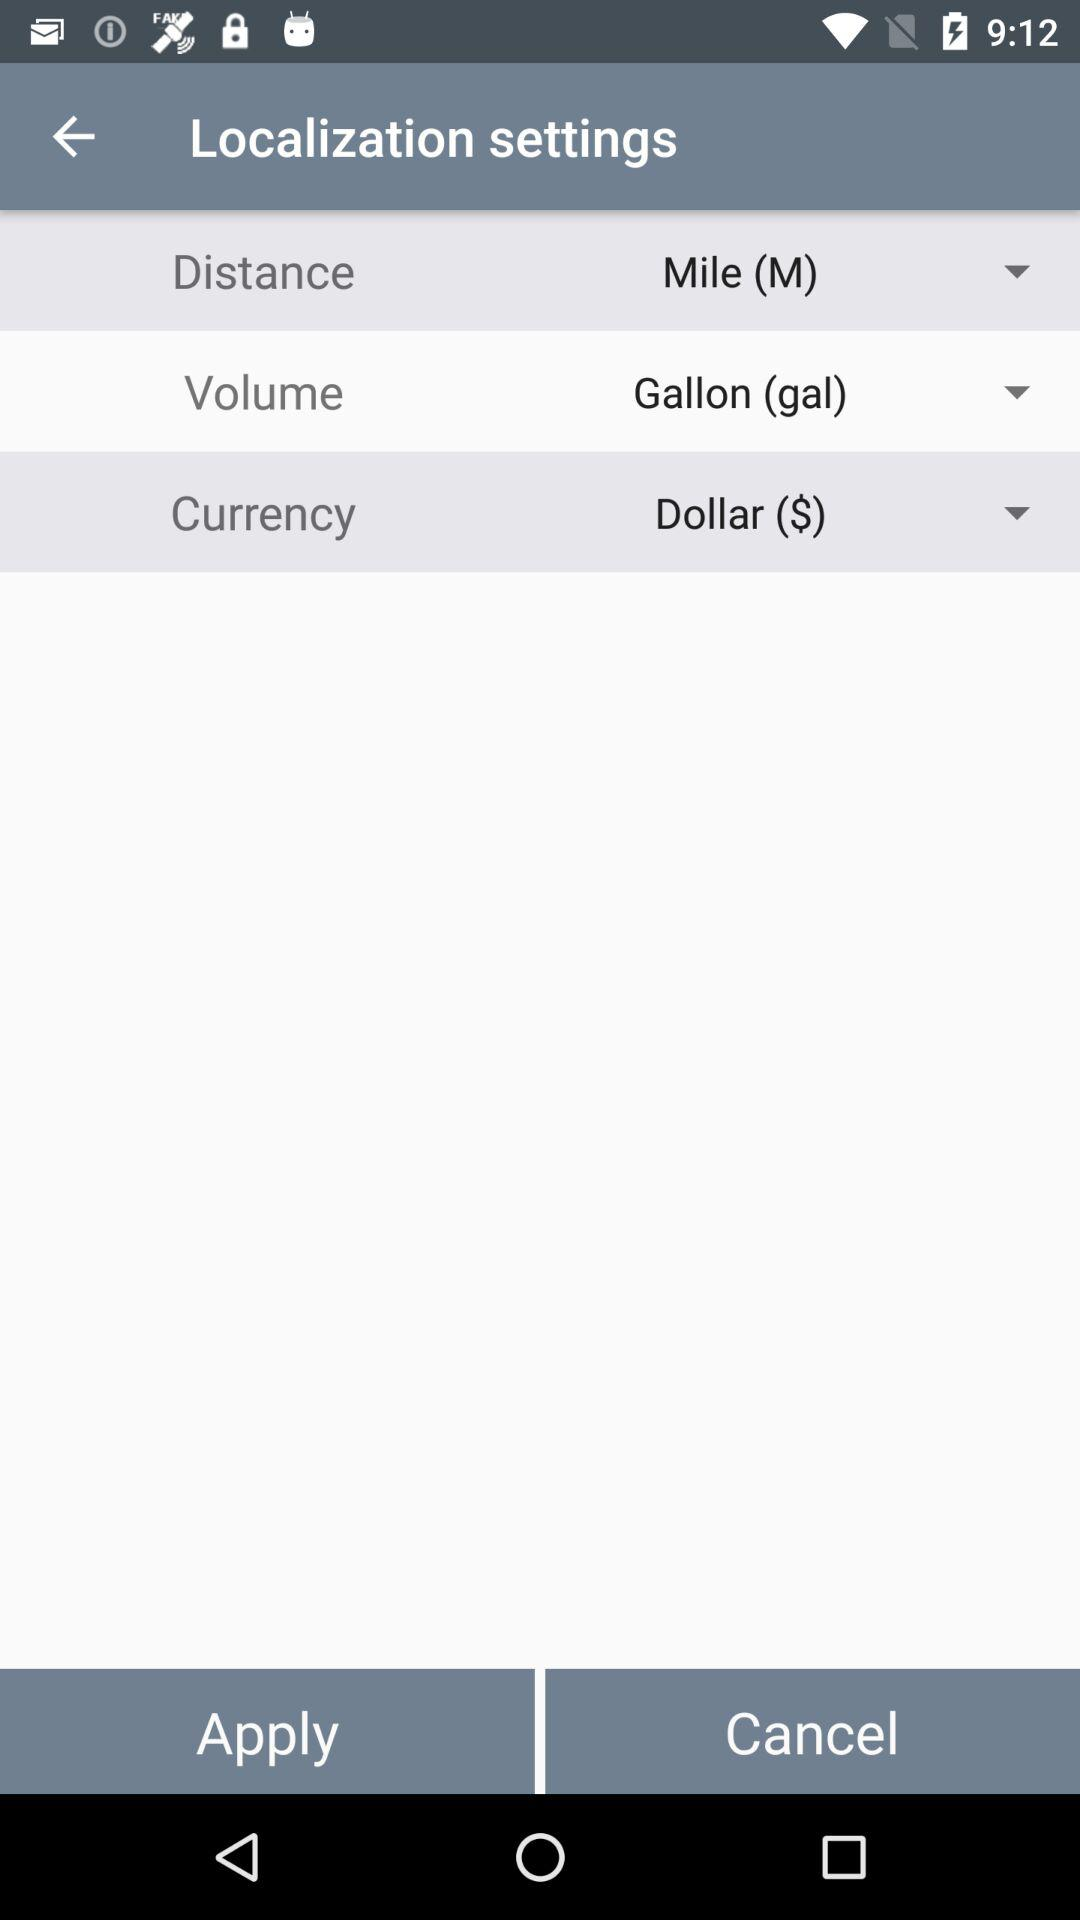What is the selected currency? The selected currency is the dollar ($). 